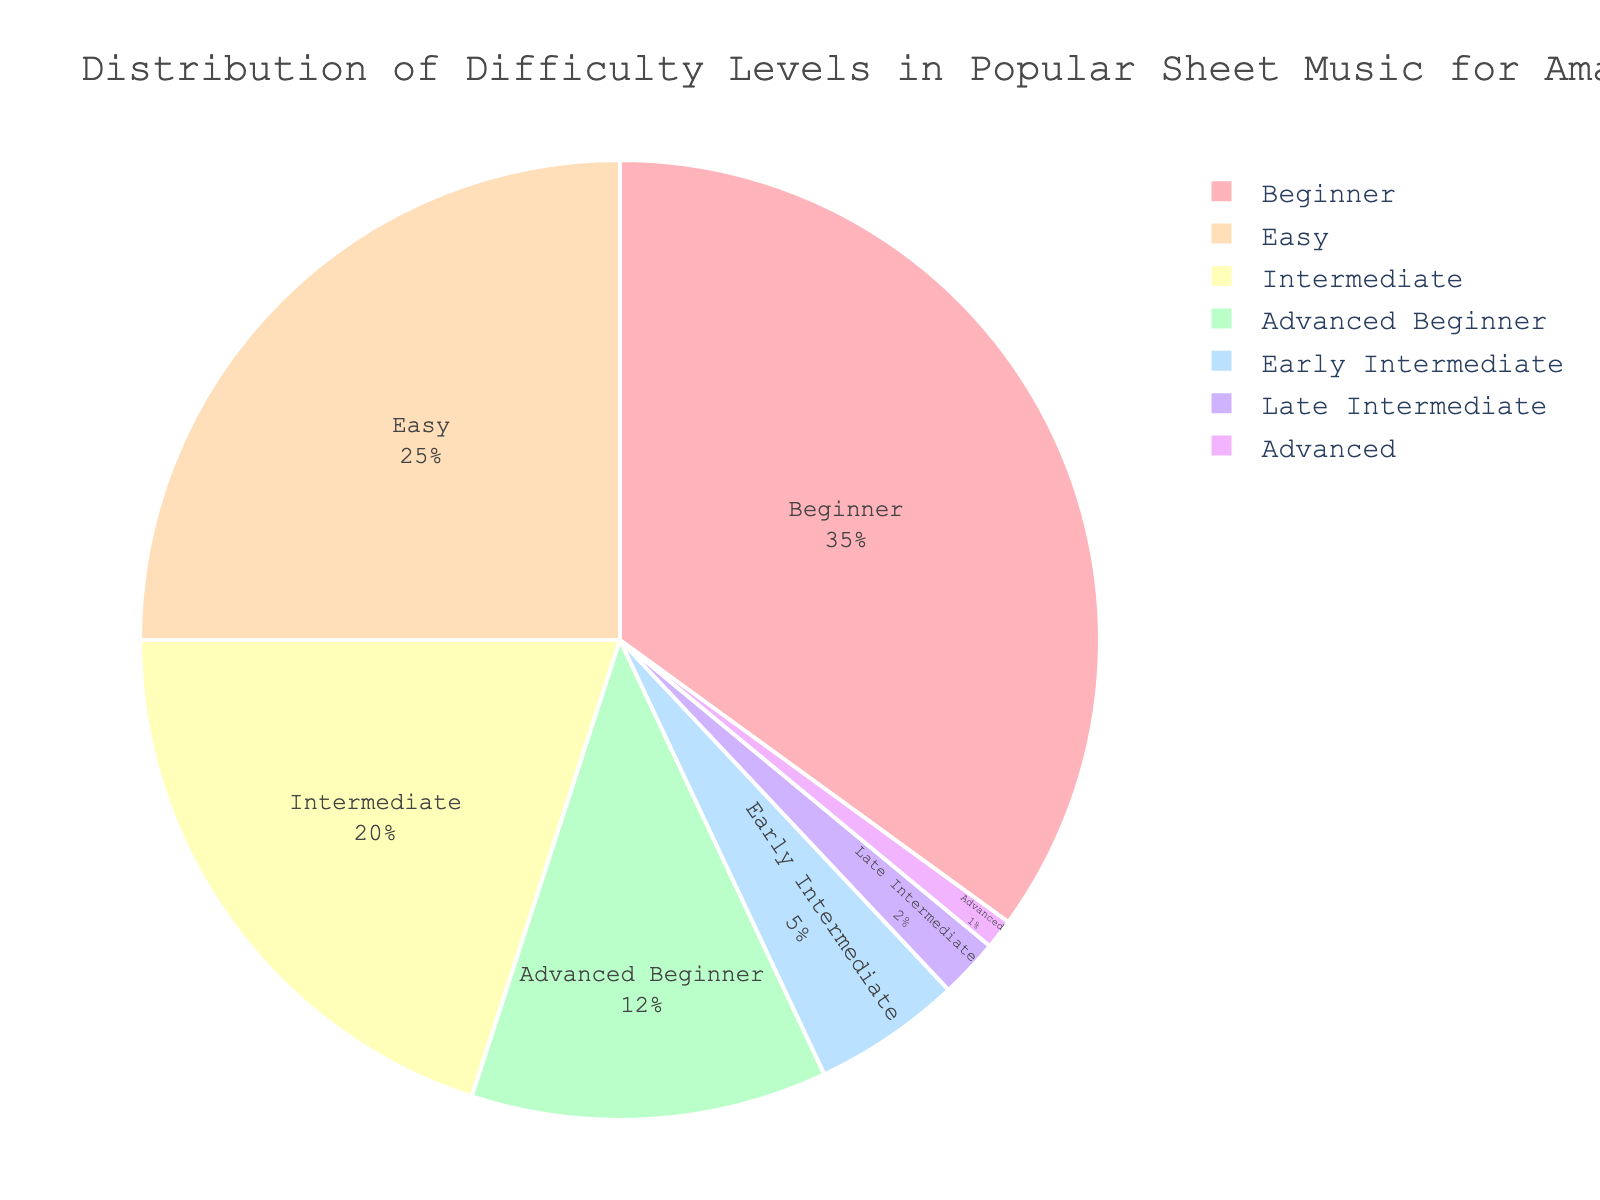What is the percentage of sheet music classified as Intermediate or more difficult? Adding the percentages for Intermediate (20%), Late Intermediate (2%), and Advanced (1%) gives us 23%.
Answer: 23% What portion of the sheet music is rated as Beginner? Referring to the pie chart, Beginner is 35%.
Answer: 35% Which difficulty level has the smallest percentage? Based on the pie chart, Advanced has the smallest percentage at 1%.
Answer: 1% How much more popular is Beginner music compared to Intermediate music? Subtract the percentage of Intermediate (20%) from that of Beginner (35%) gives us 15%.
Answer: 15% Is Easy music more popular than Advanced Beginner music? From the chart, Easy music is 25% while Advanced Beginner is 12%, so yes, Easy is more popular.
Answer: Yes What is the combined percentage of Beginner and Easy sheet music? Adding the percentages for Beginner (35%) and Easy (25%) gives us 60%.
Answer: 60% Which difficulty level has a green color, and what percentage does it represent? The pie chart shows that Early Intermediate, which is green, represents 5%.
Answer: Early Intermediate, 5% How does the percentage of Late Intermediate music compare to that of Beginner music? Beginner is 35% and Late Intermediate is 2%, so Beginner is significantly more common.
Answer: Beginner is more common What is the difference in percentage between Easy and Early Intermediate sheet music? Subtract the percentage of Early Intermediate (5%) from that of Easy (25%) gives us 20%.
Answer: 20% Which difficulty levels together make up less than 10% of the sheet music distribution? Adding Late Intermediate (2%) and Advanced (1%) results in a total of 3%, which is less than 10%.
Answer: Late Intermediate and Advanced 